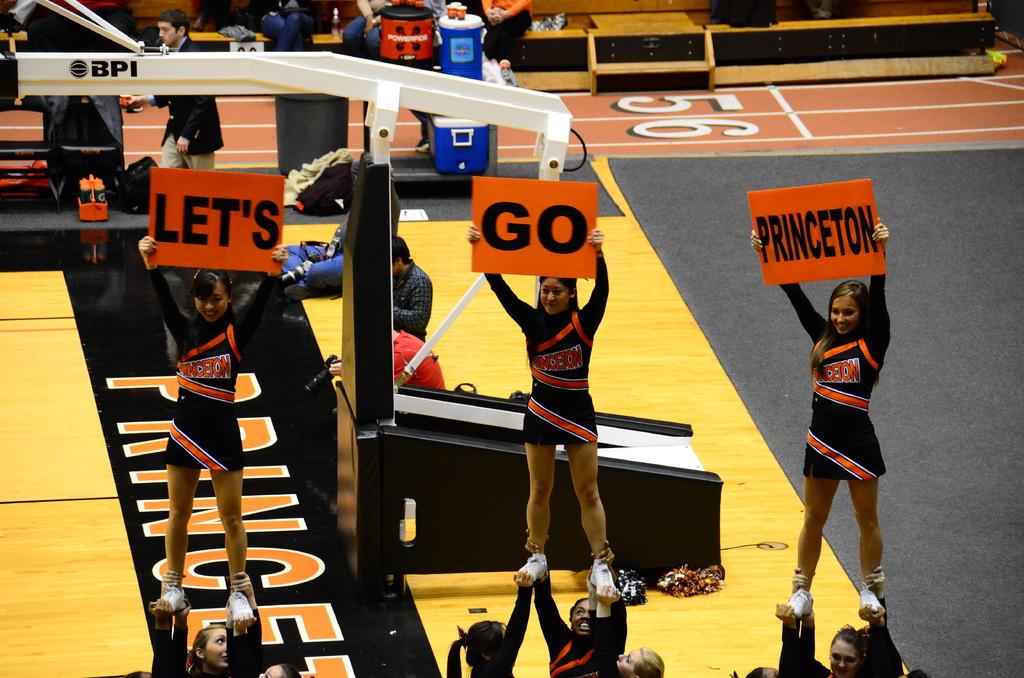<image>
Summarize the visual content of the image. THREE CHEER LEADERS FROM PRINCETON ARE MOTIVATING THE CROWD TO CHEER FOR THEIR TEAM. 